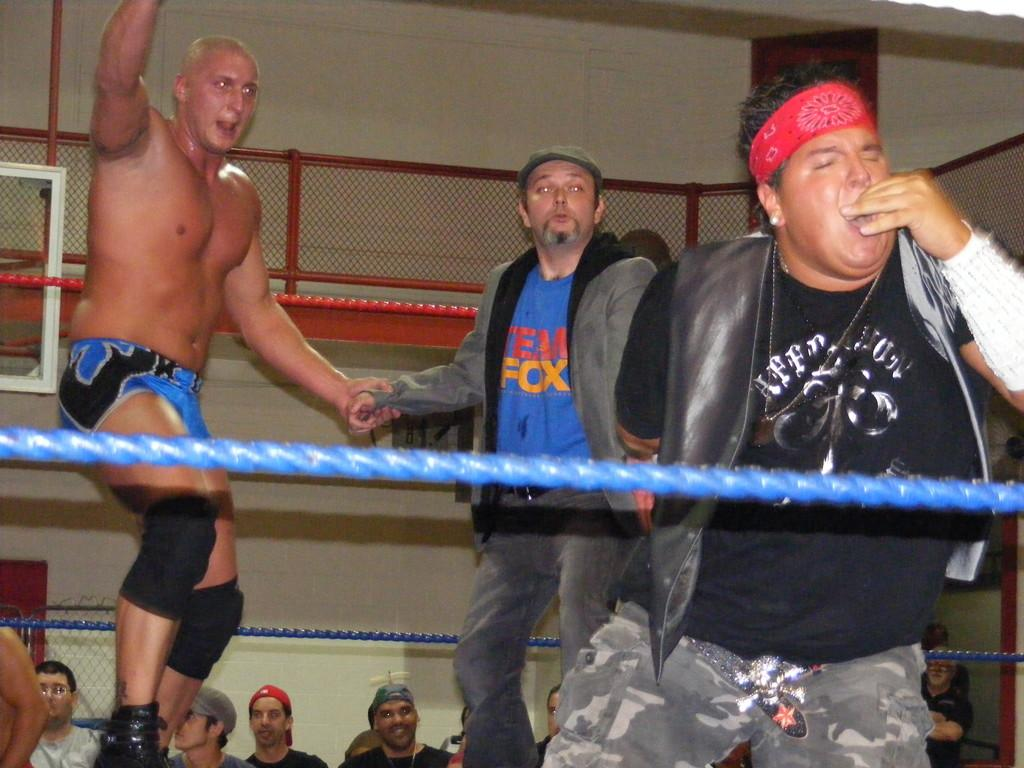<image>
Present a compact description of the photo's key features. Wrestlers in a ring with one man wearing a shirt which says "Fox". 